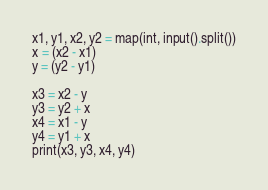Convert code to text. <code><loc_0><loc_0><loc_500><loc_500><_Python_>x1, y1, x2, y2 = map(int, input().split())
x = (x2 - x1)
y = (y2 - y1)

x3 = x2 - y
y3 = y2 + x
x4 = x1 - y
y4 = y1 + x
print(x3, y3, x4, y4)
</code> 